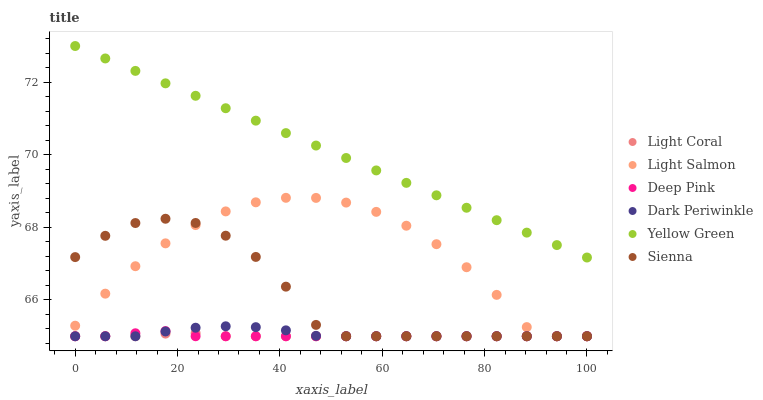Does Light Coral have the minimum area under the curve?
Answer yes or no. Yes. Does Yellow Green have the maximum area under the curve?
Answer yes or no. Yes. Does Light Salmon have the minimum area under the curve?
Answer yes or no. No. Does Light Salmon have the maximum area under the curve?
Answer yes or no. No. Is Yellow Green the smoothest?
Answer yes or no. Yes. Is Sienna the roughest?
Answer yes or no. Yes. Is Light Salmon the smoothest?
Answer yes or no. No. Is Light Salmon the roughest?
Answer yes or no. No. Does Sienna have the lowest value?
Answer yes or no. Yes. Does Yellow Green have the lowest value?
Answer yes or no. No. Does Yellow Green have the highest value?
Answer yes or no. Yes. Does Light Salmon have the highest value?
Answer yes or no. No. Is Light Coral less than Yellow Green?
Answer yes or no. Yes. Is Yellow Green greater than Dark Periwinkle?
Answer yes or no. Yes. Does Sienna intersect Light Salmon?
Answer yes or no. Yes. Is Sienna less than Light Salmon?
Answer yes or no. No. Is Sienna greater than Light Salmon?
Answer yes or no. No. Does Light Coral intersect Yellow Green?
Answer yes or no. No. 